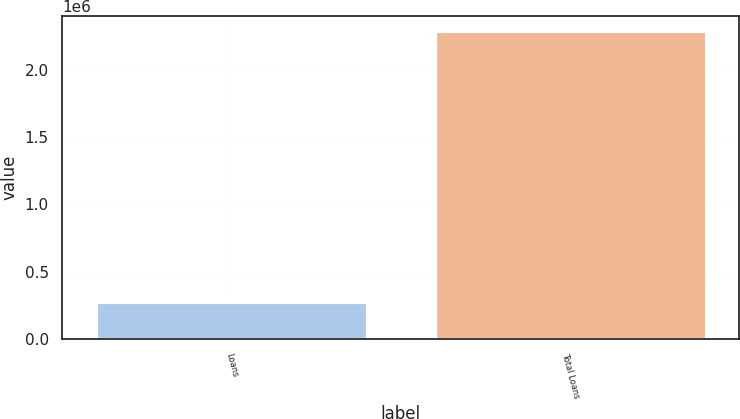<chart> <loc_0><loc_0><loc_500><loc_500><bar_chart><fcel>Loans<fcel>Total Loans<nl><fcel>272957<fcel>2.2858e+06<nl></chart> 